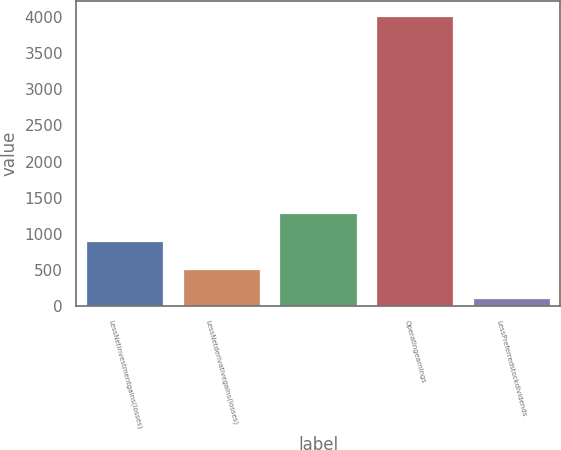Convert chart. <chart><loc_0><loc_0><loc_500><loc_500><bar_chart><fcel>LessNetinvestmentgains(losses)<fcel>LessNetderivativegains(losses)<fcel>Unnamed: 2<fcel>Operatingearnings<fcel>LessPreferredstockdividends<nl><fcel>900.4<fcel>511.2<fcel>1289.6<fcel>4014<fcel>122<nl></chart> 